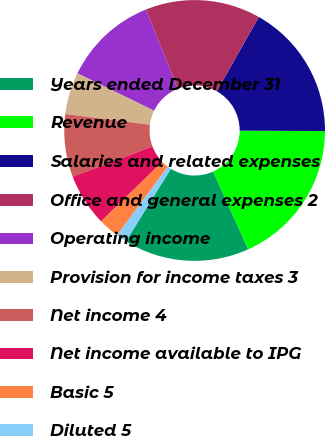<chart> <loc_0><loc_0><loc_500><loc_500><pie_chart><fcel>Years ended December 31<fcel>Revenue<fcel>Salaries and related expenses<fcel>Office and general expenses 2<fcel>Operating income<fcel>Provision for income taxes 3<fcel>Net income 4<fcel>Net income available to IPG<fcel>Basic 5<fcel>Diluted 5<nl><fcel>15.58%<fcel>18.18%<fcel>16.88%<fcel>14.29%<fcel>11.69%<fcel>5.2%<fcel>7.79%<fcel>6.49%<fcel>2.6%<fcel>1.3%<nl></chart> 